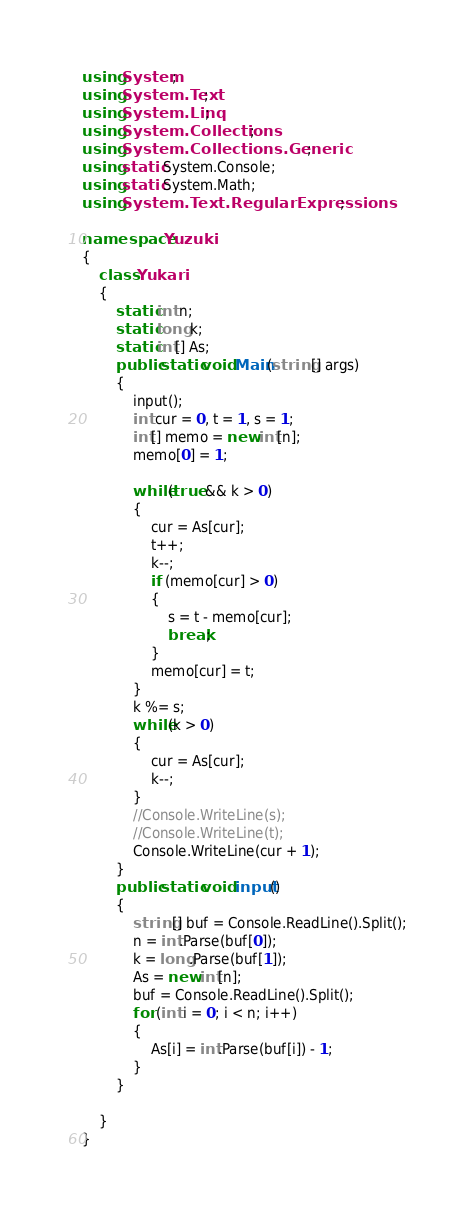Convert code to text. <code><loc_0><loc_0><loc_500><loc_500><_C#_>using System;
using System.Text;
using System.Linq;
using System.Collections;
using System.Collections.Generic;
using static System.Console;
using static System.Math;
using System.Text.RegularExpressions;

namespace Yuzuki
{
    class Yukari
    {
        static int n;
        static long k;
        static int[] As;
        public static void Main(string[] args)
        {
            input();
            int cur = 0, t = 1, s = 1;
            int[] memo = new int[n];
            memo[0] = 1;

            while(true && k > 0)
            {
                cur = As[cur];
                t++;
                k--;
                if (memo[cur] > 0)
                {
                    s = t - memo[cur];
                    break;
                }
                memo[cur] = t;
            }
            k %= s;
            while(k > 0)
            {
                cur = As[cur];
                k--;
            }
            //Console.WriteLine(s);
            //Console.WriteLine(t);
            Console.WriteLine(cur + 1);
        }
        public static void input()
        {
            string[] buf = Console.ReadLine().Split();
            n = int.Parse(buf[0]);
            k = long.Parse(buf[1]);
            As = new int[n];
            buf = Console.ReadLine().Split();
            for (int i = 0; i < n; i++)
            {
                As[i] = int.Parse(buf[i]) - 1;
            }
        }

    }
}</code> 